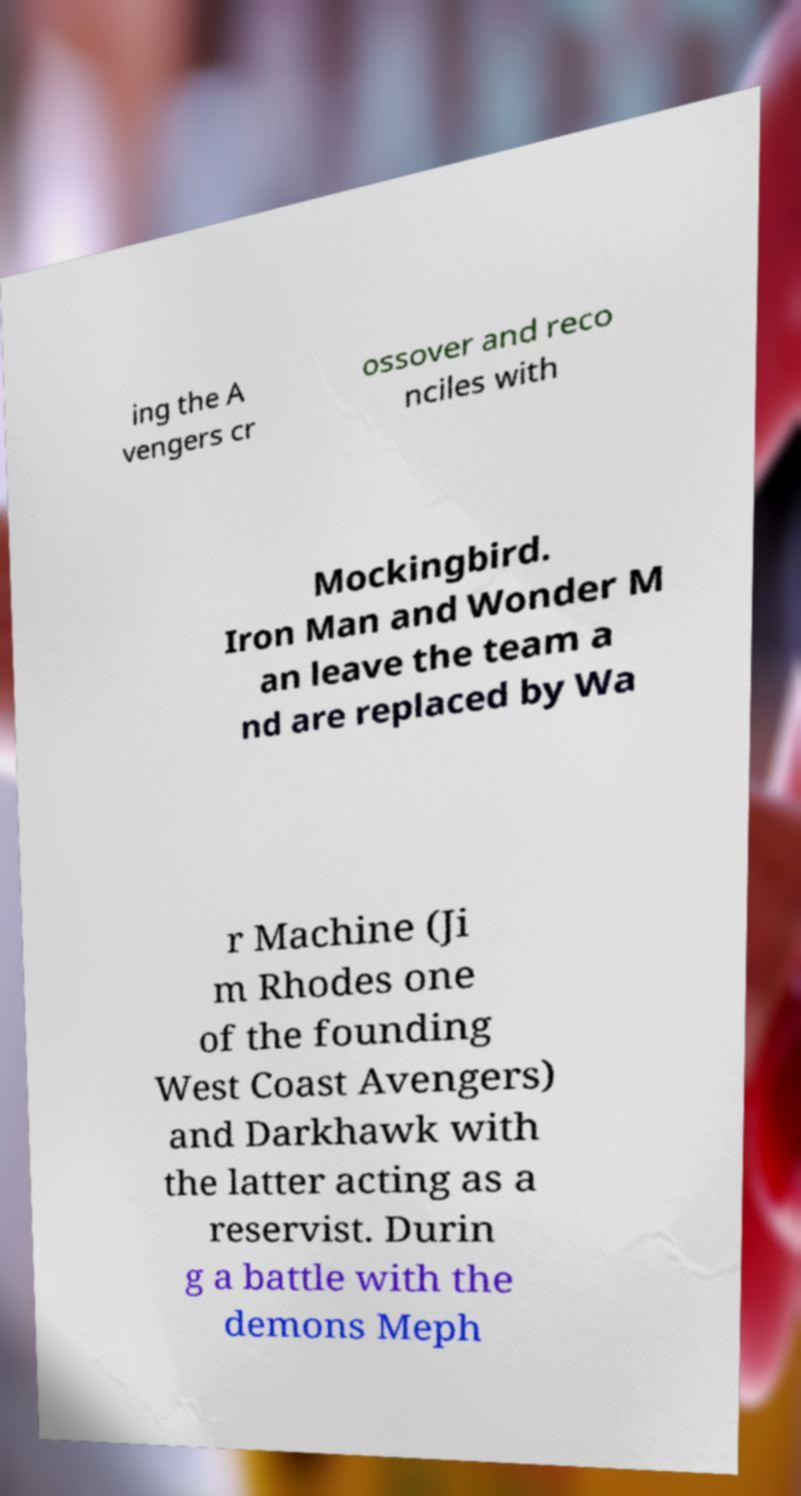Please read and relay the text visible in this image. What does it say? ing the A vengers cr ossover and reco nciles with Mockingbird. Iron Man and Wonder M an leave the team a nd are replaced by Wa r Machine (Ji m Rhodes one of the founding West Coast Avengers) and Darkhawk with the latter acting as a reservist. Durin g a battle with the demons Meph 